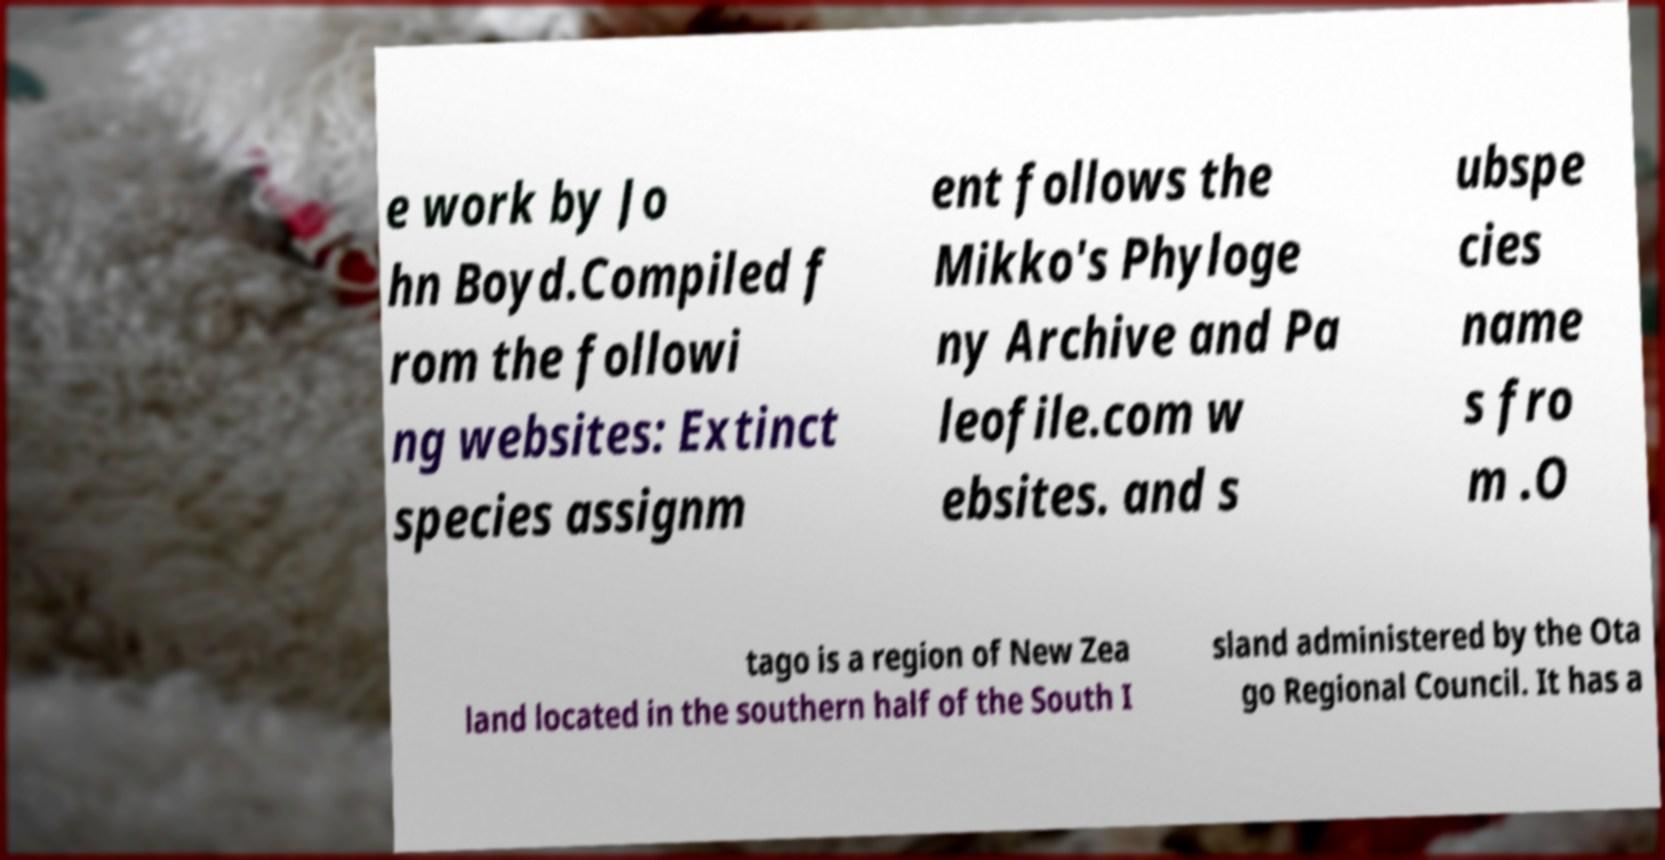I need the written content from this picture converted into text. Can you do that? e work by Jo hn Boyd.Compiled f rom the followi ng websites: Extinct species assignm ent follows the Mikko's Phyloge ny Archive and Pa leofile.com w ebsites. and s ubspe cies name s fro m .O tago is a region of New Zea land located in the southern half of the South I sland administered by the Ota go Regional Council. It has a 